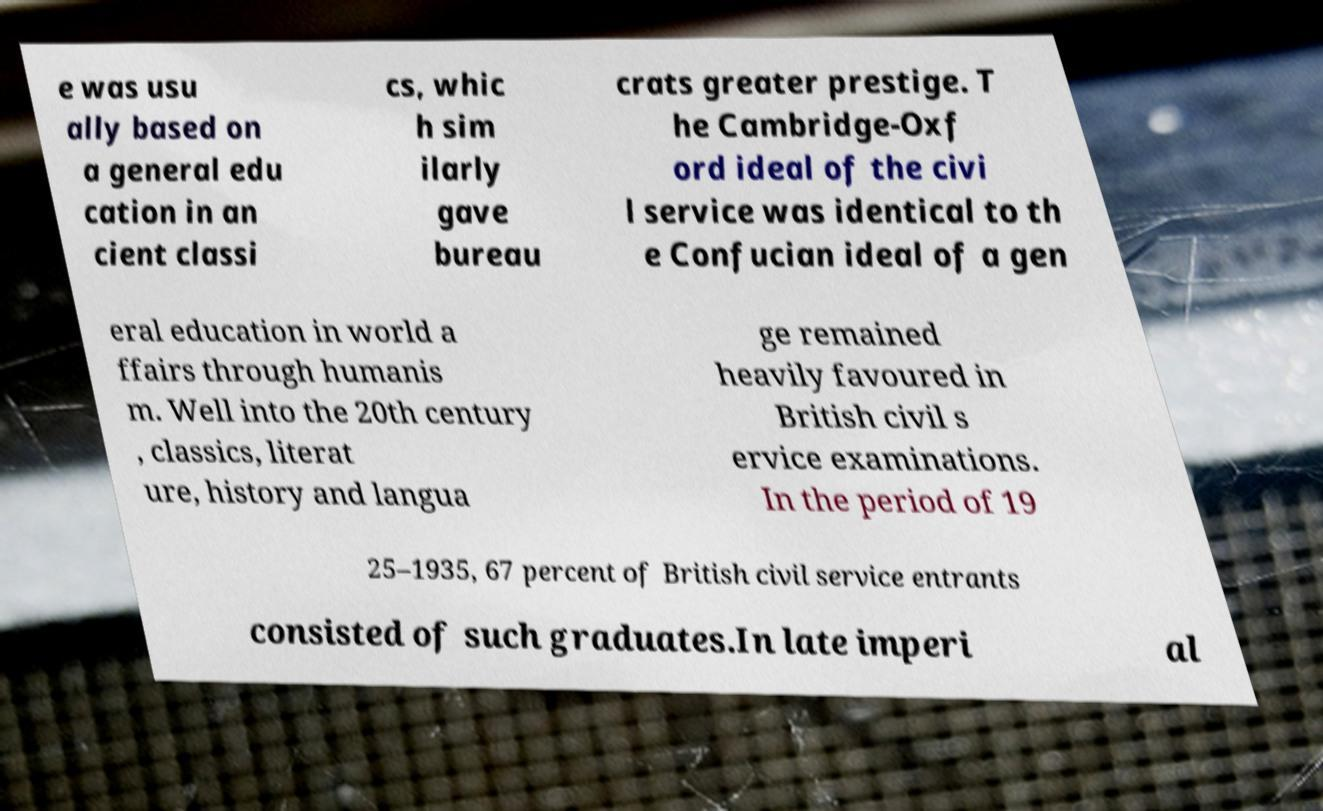For documentation purposes, I need the text within this image transcribed. Could you provide that? e was usu ally based on a general edu cation in an cient classi cs, whic h sim ilarly gave bureau crats greater prestige. T he Cambridge-Oxf ord ideal of the civi l service was identical to th e Confucian ideal of a gen eral education in world a ffairs through humanis m. Well into the 20th century , classics, literat ure, history and langua ge remained heavily favoured in British civil s ervice examinations. In the period of 19 25–1935, 67 percent of British civil service entrants consisted of such graduates.In late imperi al 